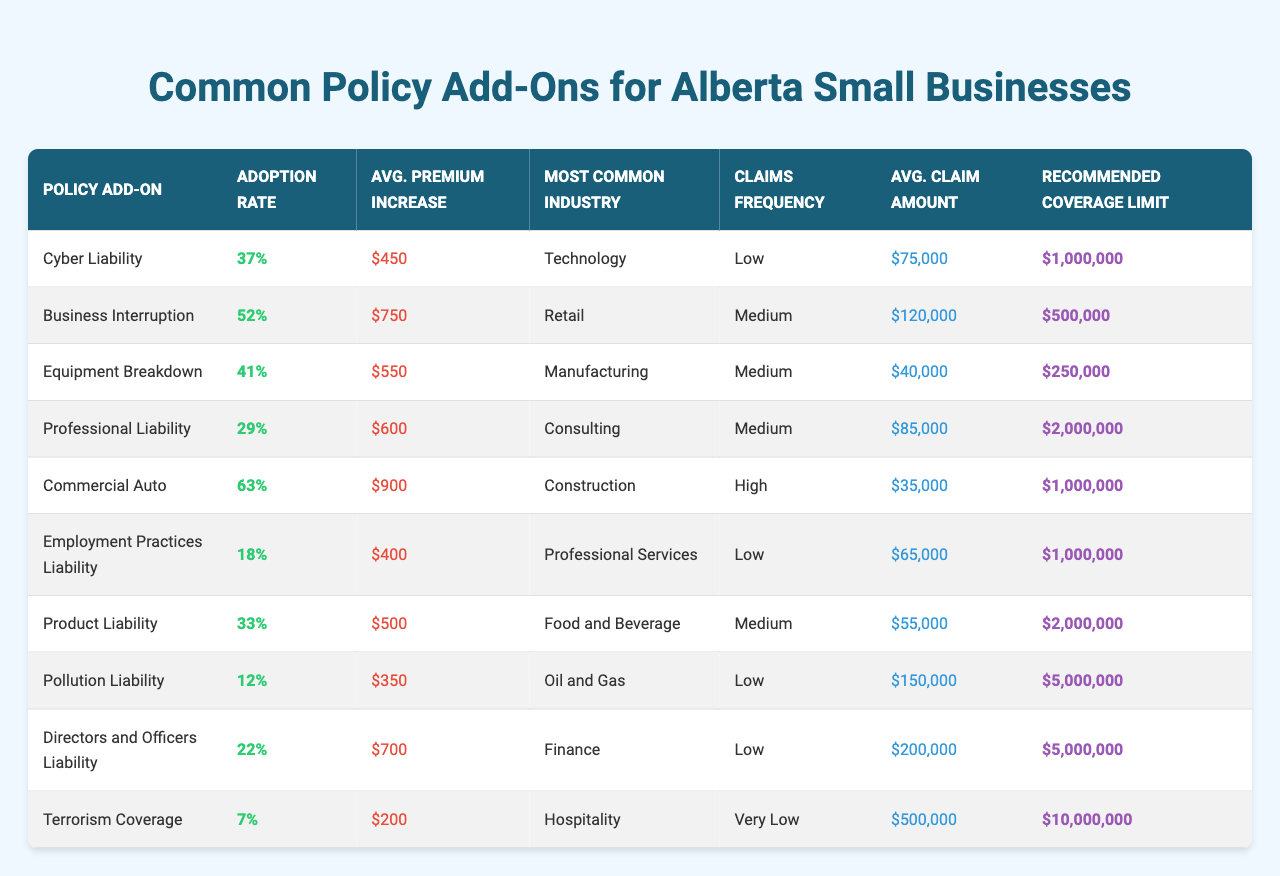What is the adoption rate of Cyber Liability? The table shows that the adoption rate for Cyber Liability is 37%. This value is located in the "Adoption Rate" column next to "Cyber Liability."
Answer: 37% Which policy add-on has the highest average premium increase? According to the table, Commercial Auto has the highest average premium increase at $900. This is seen in the "Avg. Premium Increase" column for the "Commercial Auto" row.
Answer: $900 Is there any policy add-on with a very low claims frequency? Yes, the table indicates that Terrorism Coverage has a very low frequency of claims. This can be found in the "Claims Frequency" column next to "Terrorism Coverage."
Answer: Yes What is the recommended coverage limit for Equipment Breakdown? The recommended coverage limit for Equipment Breakdown is $250,000. This is indicated in the "Recommended Coverage Limit" column corresponding to "Equipment Breakdown."
Answer: $250,000 Which policy add-on is most commonly adopted in the Construction industry? The table shows that Commercial Auto is the most commonly adopted add-on in the Construction industry as indicated in the "Most Common Industry" column for that policy.
Answer: Commercial Auto What is the average claim amount for Product Liability compared to Employment Practices Liability? The average claim amount for Product Liability is $55,000, while for Employment Practices Liability, it is $65,000. Finding both amounts in the "Avg. Claim Amount" column, we see that Employment Practices Liability has a higher average claim amount than Product Liability.
Answer: Employment Practices Liability has a higher average claim amount What is the average adoption rate of all policy add-ons? The adoption rates are 37%, 52%, 41%, 29%, 63%, 18%, 33%, 12%, 22%, and 7%. Adding these percentages gives a total of 314%, and dividing by 10 (the number of add-ons) results in an average adoption rate of 31.4%.
Answer: 31.4% Which policy add-on has the lowest claims frequency and what is its average claim amount? The table indicates that Terrorism Coverage has the lowest claims frequency rated as very low, with an average claim amount of $500,000 found in the respective columns.
Answer: Terrorism Coverage, Average claim $500,000 What is the difference in average claim amounts between the policy add-ons with the highest and lowest recommended coverage limits? The highest recommended coverage limit is $10,000,000 for Terrorism Coverage, while the lowest is $250,000 for Equipment Breakdown. Their average claim amounts are $500,000 for Terrorism Coverage and $40,000 for Equipment Breakdown, resulting in a difference of $460,000.
Answer: $460,000 